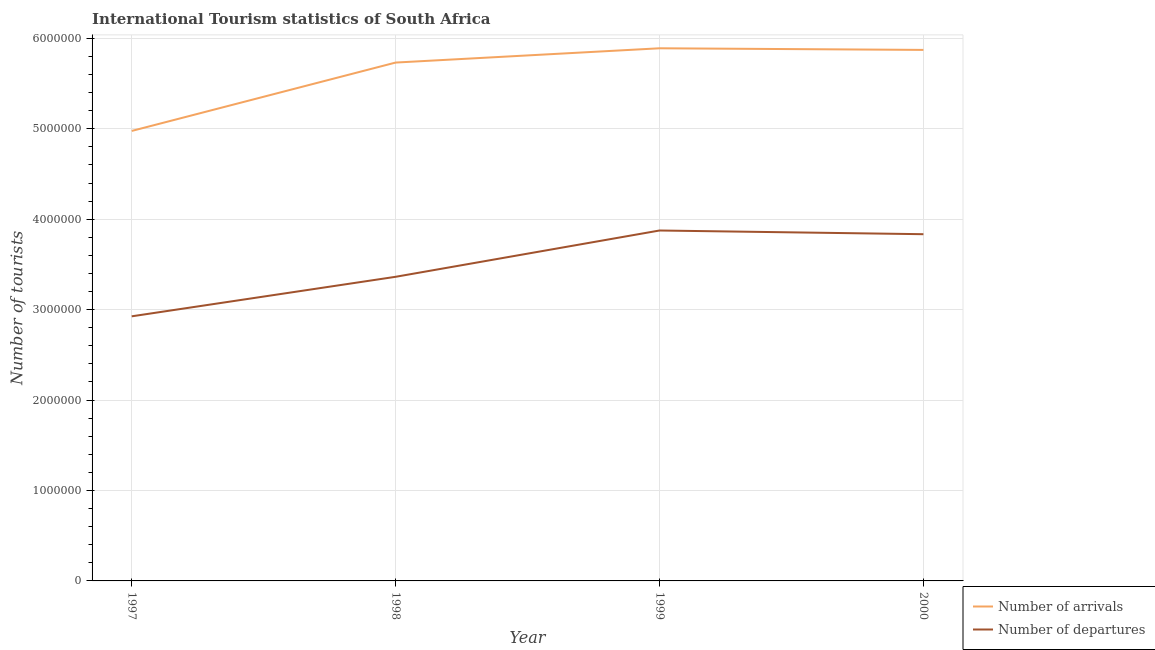How many different coloured lines are there?
Offer a very short reply. 2. What is the number of tourist departures in 1998?
Provide a short and direct response. 3.36e+06. Across all years, what is the maximum number of tourist arrivals?
Offer a very short reply. 5.89e+06. Across all years, what is the minimum number of tourist departures?
Provide a succinct answer. 2.93e+06. In which year was the number of tourist departures maximum?
Your answer should be compact. 1999. What is the total number of tourist departures in the graph?
Provide a short and direct response. 1.40e+07. What is the difference between the number of tourist arrivals in 1999 and that in 2000?
Your answer should be very brief. 1.80e+04. What is the difference between the number of tourist arrivals in 1998 and the number of tourist departures in 2000?
Give a very brief answer. 1.90e+06. What is the average number of tourist departures per year?
Provide a succinct answer. 3.50e+06. In the year 1998, what is the difference between the number of tourist departures and number of tourist arrivals?
Your response must be concise. -2.37e+06. In how many years, is the number of tourist arrivals greater than 2800000?
Make the answer very short. 4. What is the ratio of the number of tourist arrivals in 1997 to that in 1998?
Your response must be concise. 0.87. Is the number of tourist departures in 1997 less than that in 1998?
Your answer should be very brief. Yes. What is the difference between the highest and the second highest number of tourist departures?
Provide a succinct answer. 4.10e+04. What is the difference between the highest and the lowest number of tourist departures?
Give a very brief answer. 9.49e+05. In how many years, is the number of tourist departures greater than the average number of tourist departures taken over all years?
Your answer should be compact. 2. Is the sum of the number of tourist arrivals in 1999 and 2000 greater than the maximum number of tourist departures across all years?
Give a very brief answer. Yes. Does the number of tourist arrivals monotonically increase over the years?
Your response must be concise. No. Is the number of tourist arrivals strictly greater than the number of tourist departures over the years?
Provide a short and direct response. Yes. Is the number of tourist departures strictly less than the number of tourist arrivals over the years?
Your answer should be compact. Yes. How many lines are there?
Provide a succinct answer. 2. How many years are there in the graph?
Your response must be concise. 4. Are the values on the major ticks of Y-axis written in scientific E-notation?
Keep it short and to the point. No. Does the graph contain any zero values?
Your response must be concise. No. Where does the legend appear in the graph?
Make the answer very short. Bottom right. How are the legend labels stacked?
Provide a short and direct response. Vertical. What is the title of the graph?
Offer a very short reply. International Tourism statistics of South Africa. What is the label or title of the X-axis?
Provide a short and direct response. Year. What is the label or title of the Y-axis?
Make the answer very short. Number of tourists. What is the Number of tourists in Number of arrivals in 1997?
Ensure brevity in your answer.  4.98e+06. What is the Number of tourists of Number of departures in 1997?
Your answer should be very brief. 2.93e+06. What is the Number of tourists of Number of arrivals in 1998?
Offer a very short reply. 5.73e+06. What is the Number of tourists of Number of departures in 1998?
Provide a succinct answer. 3.36e+06. What is the Number of tourists in Number of arrivals in 1999?
Your answer should be compact. 5.89e+06. What is the Number of tourists in Number of departures in 1999?
Your answer should be compact. 3.88e+06. What is the Number of tourists of Number of arrivals in 2000?
Your response must be concise. 5.87e+06. What is the Number of tourists in Number of departures in 2000?
Ensure brevity in your answer.  3.83e+06. Across all years, what is the maximum Number of tourists of Number of arrivals?
Ensure brevity in your answer.  5.89e+06. Across all years, what is the maximum Number of tourists of Number of departures?
Make the answer very short. 3.88e+06. Across all years, what is the minimum Number of tourists in Number of arrivals?
Ensure brevity in your answer.  4.98e+06. Across all years, what is the minimum Number of tourists of Number of departures?
Keep it short and to the point. 2.93e+06. What is the total Number of tourists of Number of arrivals in the graph?
Your answer should be very brief. 2.25e+07. What is the total Number of tourists in Number of departures in the graph?
Offer a very short reply. 1.40e+07. What is the difference between the Number of tourists in Number of arrivals in 1997 and that in 1998?
Offer a terse response. -7.56e+05. What is the difference between the Number of tourists in Number of departures in 1997 and that in 1998?
Your response must be concise. -4.37e+05. What is the difference between the Number of tourists in Number of arrivals in 1997 and that in 1999?
Provide a short and direct response. -9.14e+05. What is the difference between the Number of tourists of Number of departures in 1997 and that in 1999?
Offer a very short reply. -9.49e+05. What is the difference between the Number of tourists in Number of arrivals in 1997 and that in 2000?
Your answer should be compact. -8.96e+05. What is the difference between the Number of tourists of Number of departures in 1997 and that in 2000?
Offer a terse response. -9.08e+05. What is the difference between the Number of tourists in Number of arrivals in 1998 and that in 1999?
Provide a short and direct response. -1.58e+05. What is the difference between the Number of tourists in Number of departures in 1998 and that in 1999?
Keep it short and to the point. -5.12e+05. What is the difference between the Number of tourists of Number of departures in 1998 and that in 2000?
Offer a very short reply. -4.71e+05. What is the difference between the Number of tourists in Number of arrivals in 1999 and that in 2000?
Your answer should be compact. 1.80e+04. What is the difference between the Number of tourists of Number of departures in 1999 and that in 2000?
Your answer should be very brief. 4.10e+04. What is the difference between the Number of tourists in Number of arrivals in 1997 and the Number of tourists in Number of departures in 1998?
Keep it short and to the point. 1.61e+06. What is the difference between the Number of tourists in Number of arrivals in 1997 and the Number of tourists in Number of departures in 1999?
Provide a short and direct response. 1.10e+06. What is the difference between the Number of tourists of Number of arrivals in 1997 and the Number of tourists of Number of departures in 2000?
Offer a very short reply. 1.14e+06. What is the difference between the Number of tourists in Number of arrivals in 1998 and the Number of tourists in Number of departures in 1999?
Your answer should be compact. 1.86e+06. What is the difference between the Number of tourists in Number of arrivals in 1998 and the Number of tourists in Number of departures in 2000?
Offer a very short reply. 1.90e+06. What is the difference between the Number of tourists of Number of arrivals in 1999 and the Number of tourists of Number of departures in 2000?
Your response must be concise. 2.06e+06. What is the average Number of tourists of Number of arrivals per year?
Offer a very short reply. 5.62e+06. What is the average Number of tourists of Number of departures per year?
Make the answer very short. 3.50e+06. In the year 1997, what is the difference between the Number of tourists of Number of arrivals and Number of tourists of Number of departures?
Make the answer very short. 2.05e+06. In the year 1998, what is the difference between the Number of tourists in Number of arrivals and Number of tourists in Number of departures?
Make the answer very short. 2.37e+06. In the year 1999, what is the difference between the Number of tourists in Number of arrivals and Number of tourists in Number of departures?
Your answer should be compact. 2.02e+06. In the year 2000, what is the difference between the Number of tourists of Number of arrivals and Number of tourists of Number of departures?
Ensure brevity in your answer.  2.04e+06. What is the ratio of the Number of tourists of Number of arrivals in 1997 to that in 1998?
Provide a succinct answer. 0.87. What is the ratio of the Number of tourists in Number of departures in 1997 to that in 1998?
Give a very brief answer. 0.87. What is the ratio of the Number of tourists of Number of arrivals in 1997 to that in 1999?
Make the answer very short. 0.84. What is the ratio of the Number of tourists in Number of departures in 1997 to that in 1999?
Your answer should be very brief. 0.76. What is the ratio of the Number of tourists in Number of arrivals in 1997 to that in 2000?
Your response must be concise. 0.85. What is the ratio of the Number of tourists in Number of departures in 1997 to that in 2000?
Make the answer very short. 0.76. What is the ratio of the Number of tourists of Number of arrivals in 1998 to that in 1999?
Give a very brief answer. 0.97. What is the ratio of the Number of tourists of Number of departures in 1998 to that in 1999?
Keep it short and to the point. 0.87. What is the ratio of the Number of tourists of Number of arrivals in 1998 to that in 2000?
Keep it short and to the point. 0.98. What is the ratio of the Number of tourists in Number of departures in 1998 to that in 2000?
Keep it short and to the point. 0.88. What is the ratio of the Number of tourists in Number of arrivals in 1999 to that in 2000?
Give a very brief answer. 1. What is the ratio of the Number of tourists in Number of departures in 1999 to that in 2000?
Provide a succinct answer. 1.01. What is the difference between the highest and the second highest Number of tourists in Number of arrivals?
Offer a very short reply. 1.80e+04. What is the difference between the highest and the second highest Number of tourists of Number of departures?
Provide a short and direct response. 4.10e+04. What is the difference between the highest and the lowest Number of tourists of Number of arrivals?
Your answer should be compact. 9.14e+05. What is the difference between the highest and the lowest Number of tourists in Number of departures?
Provide a succinct answer. 9.49e+05. 